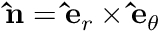Convert formula to latex. <formula><loc_0><loc_0><loc_500><loc_500>\hat { n } = \hat { e } _ { r } \times \hat { e } _ { \theta }</formula> 